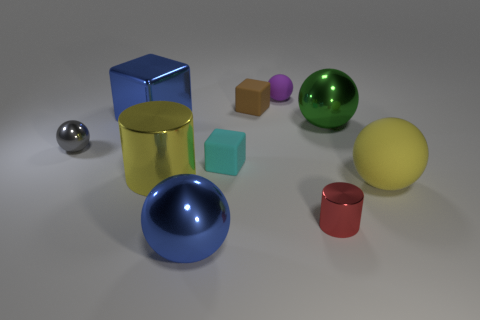Add 3 tiny blue matte objects. How many tiny blue matte objects exist? 3 Subtract all yellow cylinders. How many cylinders are left? 1 Subtract all big yellow balls. How many balls are left? 4 Subtract 0 cyan balls. How many objects are left? 10 Subtract all cylinders. How many objects are left? 8 Subtract 3 balls. How many balls are left? 2 Subtract all cyan spheres. Subtract all gray cubes. How many spheres are left? 5 Subtract all gray balls. How many yellow cylinders are left? 1 Subtract all tiny metallic balls. Subtract all large cubes. How many objects are left? 8 Add 8 blue cubes. How many blue cubes are left? 9 